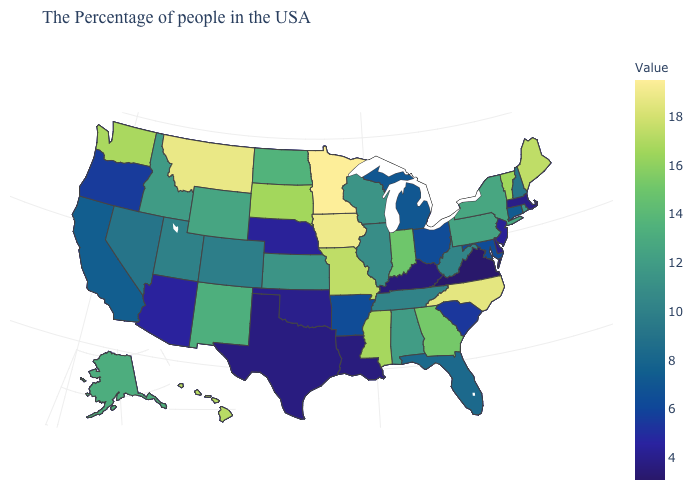Does Idaho have the highest value in the USA?
Be succinct. No. 